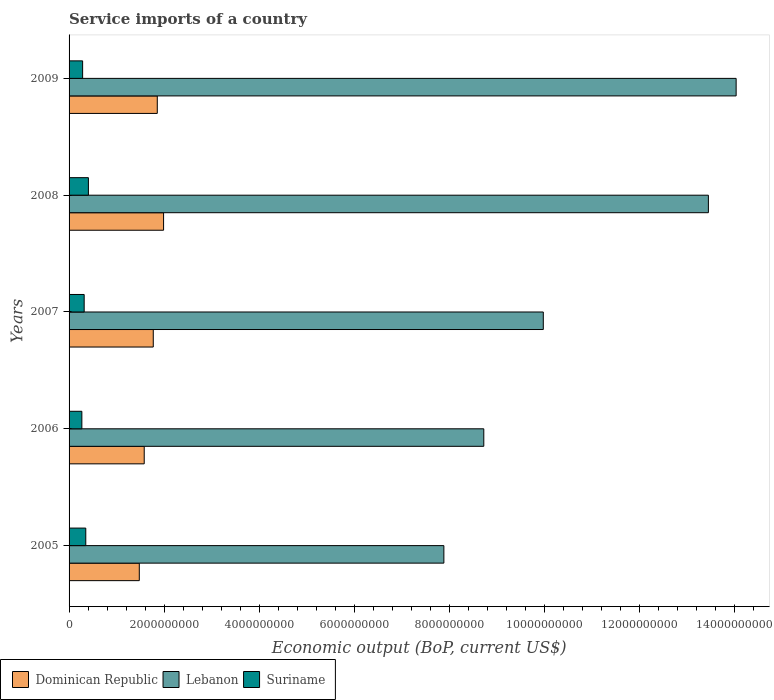How many different coloured bars are there?
Offer a terse response. 3. How many bars are there on the 1st tick from the top?
Your response must be concise. 3. What is the label of the 4th group of bars from the top?
Your answer should be very brief. 2006. In how many cases, is the number of bars for a given year not equal to the number of legend labels?
Your response must be concise. 0. What is the service imports in Lebanon in 2008?
Give a very brief answer. 1.35e+1. Across all years, what is the maximum service imports in Suriname?
Ensure brevity in your answer.  4.07e+08. Across all years, what is the minimum service imports in Dominican Republic?
Make the answer very short. 1.48e+09. In which year was the service imports in Lebanon minimum?
Offer a very short reply. 2005. What is the total service imports in Suriname in the graph?
Provide a short and direct response. 1.63e+09. What is the difference between the service imports in Lebanon in 2005 and that in 2007?
Your response must be concise. -2.09e+09. What is the difference between the service imports in Lebanon in 2008 and the service imports in Dominican Republic in 2007?
Make the answer very short. 1.17e+1. What is the average service imports in Dominican Republic per year?
Keep it short and to the point. 1.74e+09. In the year 2007, what is the difference between the service imports in Dominican Republic and service imports in Lebanon?
Your answer should be compact. -8.21e+09. What is the ratio of the service imports in Dominican Republic in 2005 to that in 2009?
Provide a short and direct response. 0.8. Is the service imports in Dominican Republic in 2005 less than that in 2009?
Give a very brief answer. Yes. What is the difference between the highest and the second highest service imports in Dominican Republic?
Your answer should be compact. 1.32e+08. What is the difference between the highest and the lowest service imports in Suriname?
Give a very brief answer. 1.38e+08. What does the 3rd bar from the top in 2007 represents?
Your answer should be very brief. Dominican Republic. What does the 2nd bar from the bottom in 2006 represents?
Keep it short and to the point. Lebanon. Is it the case that in every year, the sum of the service imports in Dominican Republic and service imports in Suriname is greater than the service imports in Lebanon?
Your answer should be compact. No. How many bars are there?
Provide a succinct answer. 15. Are all the bars in the graph horizontal?
Your answer should be very brief. Yes. What is the difference between two consecutive major ticks on the X-axis?
Your answer should be compact. 2.00e+09. Does the graph contain any zero values?
Provide a succinct answer. No. Does the graph contain grids?
Offer a very short reply. No. Where does the legend appear in the graph?
Give a very brief answer. Bottom left. How are the legend labels stacked?
Your response must be concise. Horizontal. What is the title of the graph?
Your answer should be compact. Service imports of a country. What is the label or title of the X-axis?
Offer a terse response. Economic output (BoP, current US$). What is the Economic output (BoP, current US$) of Dominican Republic in 2005?
Make the answer very short. 1.48e+09. What is the Economic output (BoP, current US$) of Lebanon in 2005?
Offer a terse response. 7.89e+09. What is the Economic output (BoP, current US$) in Suriname in 2005?
Your response must be concise. 3.52e+08. What is the Economic output (BoP, current US$) of Dominican Republic in 2006?
Your response must be concise. 1.58e+09. What is the Economic output (BoP, current US$) in Lebanon in 2006?
Give a very brief answer. 8.73e+09. What is the Economic output (BoP, current US$) in Suriname in 2006?
Your answer should be very brief. 2.69e+08. What is the Economic output (BoP, current US$) in Dominican Republic in 2007?
Your answer should be compact. 1.77e+09. What is the Economic output (BoP, current US$) in Lebanon in 2007?
Provide a short and direct response. 9.98e+09. What is the Economic output (BoP, current US$) of Suriname in 2007?
Make the answer very short. 3.18e+08. What is the Economic output (BoP, current US$) in Dominican Republic in 2008?
Provide a short and direct response. 1.99e+09. What is the Economic output (BoP, current US$) of Lebanon in 2008?
Make the answer very short. 1.35e+1. What is the Economic output (BoP, current US$) in Suriname in 2008?
Offer a terse response. 4.07e+08. What is the Economic output (BoP, current US$) of Dominican Republic in 2009?
Offer a very short reply. 1.86e+09. What is the Economic output (BoP, current US$) of Lebanon in 2009?
Offer a terse response. 1.40e+1. What is the Economic output (BoP, current US$) of Suriname in 2009?
Provide a succinct answer. 2.85e+08. Across all years, what is the maximum Economic output (BoP, current US$) of Dominican Republic?
Give a very brief answer. 1.99e+09. Across all years, what is the maximum Economic output (BoP, current US$) in Lebanon?
Provide a succinct answer. 1.40e+1. Across all years, what is the maximum Economic output (BoP, current US$) of Suriname?
Offer a very short reply. 4.07e+08. Across all years, what is the minimum Economic output (BoP, current US$) of Dominican Republic?
Ensure brevity in your answer.  1.48e+09. Across all years, what is the minimum Economic output (BoP, current US$) of Lebanon?
Provide a short and direct response. 7.89e+09. Across all years, what is the minimum Economic output (BoP, current US$) of Suriname?
Make the answer very short. 2.69e+08. What is the total Economic output (BoP, current US$) in Dominican Republic in the graph?
Your response must be concise. 8.68e+09. What is the total Economic output (BoP, current US$) in Lebanon in the graph?
Your response must be concise. 5.41e+1. What is the total Economic output (BoP, current US$) of Suriname in the graph?
Offer a very short reply. 1.63e+09. What is the difference between the Economic output (BoP, current US$) in Dominican Republic in 2005 and that in 2006?
Your response must be concise. -1.04e+08. What is the difference between the Economic output (BoP, current US$) of Lebanon in 2005 and that in 2006?
Your answer should be very brief. -8.40e+08. What is the difference between the Economic output (BoP, current US$) of Suriname in 2005 and that in 2006?
Your response must be concise. 8.25e+07. What is the difference between the Economic output (BoP, current US$) of Dominican Republic in 2005 and that in 2007?
Provide a short and direct response. -2.94e+08. What is the difference between the Economic output (BoP, current US$) in Lebanon in 2005 and that in 2007?
Offer a terse response. -2.09e+09. What is the difference between the Economic output (BoP, current US$) of Suriname in 2005 and that in 2007?
Your response must be concise. 3.39e+07. What is the difference between the Economic output (BoP, current US$) in Dominican Republic in 2005 and that in 2008?
Provide a short and direct response. -5.11e+08. What is the difference between the Economic output (BoP, current US$) in Lebanon in 2005 and that in 2008?
Provide a succinct answer. -5.57e+09. What is the difference between the Economic output (BoP, current US$) in Suriname in 2005 and that in 2008?
Your response must be concise. -5.54e+07. What is the difference between the Economic output (BoP, current US$) of Dominican Republic in 2005 and that in 2009?
Give a very brief answer. -3.79e+08. What is the difference between the Economic output (BoP, current US$) in Lebanon in 2005 and that in 2009?
Ensure brevity in your answer.  -6.15e+09. What is the difference between the Economic output (BoP, current US$) of Suriname in 2005 and that in 2009?
Your answer should be very brief. 6.65e+07. What is the difference between the Economic output (BoP, current US$) of Dominican Republic in 2006 and that in 2007?
Your answer should be compact. -1.90e+08. What is the difference between the Economic output (BoP, current US$) of Lebanon in 2006 and that in 2007?
Make the answer very short. -1.25e+09. What is the difference between the Economic output (BoP, current US$) in Suriname in 2006 and that in 2007?
Give a very brief answer. -4.86e+07. What is the difference between the Economic output (BoP, current US$) of Dominican Republic in 2006 and that in 2008?
Offer a very short reply. -4.07e+08. What is the difference between the Economic output (BoP, current US$) of Lebanon in 2006 and that in 2008?
Make the answer very short. -4.73e+09. What is the difference between the Economic output (BoP, current US$) of Suriname in 2006 and that in 2008?
Ensure brevity in your answer.  -1.38e+08. What is the difference between the Economic output (BoP, current US$) of Dominican Republic in 2006 and that in 2009?
Your answer should be very brief. -2.75e+08. What is the difference between the Economic output (BoP, current US$) of Lebanon in 2006 and that in 2009?
Provide a succinct answer. -5.31e+09. What is the difference between the Economic output (BoP, current US$) in Suriname in 2006 and that in 2009?
Provide a short and direct response. -1.60e+07. What is the difference between the Economic output (BoP, current US$) in Dominican Republic in 2007 and that in 2008?
Your response must be concise. -2.17e+08. What is the difference between the Economic output (BoP, current US$) of Lebanon in 2007 and that in 2008?
Your answer should be compact. -3.48e+09. What is the difference between the Economic output (BoP, current US$) in Suriname in 2007 and that in 2008?
Your answer should be very brief. -8.93e+07. What is the difference between the Economic output (BoP, current US$) in Dominican Republic in 2007 and that in 2009?
Ensure brevity in your answer.  -8.46e+07. What is the difference between the Economic output (BoP, current US$) in Lebanon in 2007 and that in 2009?
Provide a succinct answer. -4.06e+09. What is the difference between the Economic output (BoP, current US$) in Suriname in 2007 and that in 2009?
Ensure brevity in your answer.  3.26e+07. What is the difference between the Economic output (BoP, current US$) of Dominican Republic in 2008 and that in 2009?
Provide a short and direct response. 1.32e+08. What is the difference between the Economic output (BoP, current US$) in Lebanon in 2008 and that in 2009?
Make the answer very short. -5.84e+08. What is the difference between the Economic output (BoP, current US$) in Suriname in 2008 and that in 2009?
Give a very brief answer. 1.22e+08. What is the difference between the Economic output (BoP, current US$) in Dominican Republic in 2005 and the Economic output (BoP, current US$) in Lebanon in 2006?
Offer a terse response. -7.25e+09. What is the difference between the Economic output (BoP, current US$) in Dominican Republic in 2005 and the Economic output (BoP, current US$) in Suriname in 2006?
Your answer should be very brief. 1.21e+09. What is the difference between the Economic output (BoP, current US$) in Lebanon in 2005 and the Economic output (BoP, current US$) in Suriname in 2006?
Keep it short and to the point. 7.62e+09. What is the difference between the Economic output (BoP, current US$) of Dominican Republic in 2005 and the Economic output (BoP, current US$) of Lebanon in 2007?
Ensure brevity in your answer.  -8.50e+09. What is the difference between the Economic output (BoP, current US$) in Dominican Republic in 2005 and the Economic output (BoP, current US$) in Suriname in 2007?
Your answer should be very brief. 1.16e+09. What is the difference between the Economic output (BoP, current US$) in Lebanon in 2005 and the Economic output (BoP, current US$) in Suriname in 2007?
Your answer should be very brief. 7.57e+09. What is the difference between the Economic output (BoP, current US$) of Dominican Republic in 2005 and the Economic output (BoP, current US$) of Lebanon in 2008?
Your answer should be compact. -1.20e+1. What is the difference between the Economic output (BoP, current US$) in Dominican Republic in 2005 and the Economic output (BoP, current US$) in Suriname in 2008?
Offer a terse response. 1.07e+09. What is the difference between the Economic output (BoP, current US$) of Lebanon in 2005 and the Economic output (BoP, current US$) of Suriname in 2008?
Give a very brief answer. 7.48e+09. What is the difference between the Economic output (BoP, current US$) of Dominican Republic in 2005 and the Economic output (BoP, current US$) of Lebanon in 2009?
Keep it short and to the point. -1.26e+1. What is the difference between the Economic output (BoP, current US$) in Dominican Republic in 2005 and the Economic output (BoP, current US$) in Suriname in 2009?
Your answer should be very brief. 1.19e+09. What is the difference between the Economic output (BoP, current US$) of Lebanon in 2005 and the Economic output (BoP, current US$) of Suriname in 2009?
Provide a succinct answer. 7.60e+09. What is the difference between the Economic output (BoP, current US$) of Dominican Republic in 2006 and the Economic output (BoP, current US$) of Lebanon in 2007?
Your answer should be very brief. -8.40e+09. What is the difference between the Economic output (BoP, current US$) of Dominican Republic in 2006 and the Economic output (BoP, current US$) of Suriname in 2007?
Make the answer very short. 1.26e+09. What is the difference between the Economic output (BoP, current US$) of Lebanon in 2006 and the Economic output (BoP, current US$) of Suriname in 2007?
Give a very brief answer. 8.41e+09. What is the difference between the Economic output (BoP, current US$) of Dominican Republic in 2006 and the Economic output (BoP, current US$) of Lebanon in 2008?
Your answer should be very brief. -1.19e+1. What is the difference between the Economic output (BoP, current US$) of Dominican Republic in 2006 and the Economic output (BoP, current US$) of Suriname in 2008?
Offer a terse response. 1.17e+09. What is the difference between the Economic output (BoP, current US$) of Lebanon in 2006 and the Economic output (BoP, current US$) of Suriname in 2008?
Your response must be concise. 8.32e+09. What is the difference between the Economic output (BoP, current US$) of Dominican Republic in 2006 and the Economic output (BoP, current US$) of Lebanon in 2009?
Make the answer very short. -1.25e+1. What is the difference between the Economic output (BoP, current US$) in Dominican Republic in 2006 and the Economic output (BoP, current US$) in Suriname in 2009?
Offer a very short reply. 1.30e+09. What is the difference between the Economic output (BoP, current US$) of Lebanon in 2006 and the Economic output (BoP, current US$) of Suriname in 2009?
Your answer should be compact. 8.45e+09. What is the difference between the Economic output (BoP, current US$) of Dominican Republic in 2007 and the Economic output (BoP, current US$) of Lebanon in 2008?
Keep it short and to the point. -1.17e+1. What is the difference between the Economic output (BoP, current US$) of Dominican Republic in 2007 and the Economic output (BoP, current US$) of Suriname in 2008?
Provide a short and direct response. 1.37e+09. What is the difference between the Economic output (BoP, current US$) in Lebanon in 2007 and the Economic output (BoP, current US$) in Suriname in 2008?
Offer a very short reply. 9.58e+09. What is the difference between the Economic output (BoP, current US$) of Dominican Republic in 2007 and the Economic output (BoP, current US$) of Lebanon in 2009?
Provide a short and direct response. -1.23e+1. What is the difference between the Economic output (BoP, current US$) in Dominican Republic in 2007 and the Economic output (BoP, current US$) in Suriname in 2009?
Make the answer very short. 1.49e+09. What is the difference between the Economic output (BoP, current US$) of Lebanon in 2007 and the Economic output (BoP, current US$) of Suriname in 2009?
Make the answer very short. 9.70e+09. What is the difference between the Economic output (BoP, current US$) in Dominican Republic in 2008 and the Economic output (BoP, current US$) in Lebanon in 2009?
Give a very brief answer. -1.21e+1. What is the difference between the Economic output (BoP, current US$) of Dominican Republic in 2008 and the Economic output (BoP, current US$) of Suriname in 2009?
Provide a succinct answer. 1.70e+09. What is the difference between the Economic output (BoP, current US$) in Lebanon in 2008 and the Economic output (BoP, current US$) in Suriname in 2009?
Make the answer very short. 1.32e+1. What is the average Economic output (BoP, current US$) of Dominican Republic per year?
Make the answer very short. 1.74e+09. What is the average Economic output (BoP, current US$) in Lebanon per year?
Keep it short and to the point. 1.08e+1. What is the average Economic output (BoP, current US$) of Suriname per year?
Your response must be concise. 3.26e+08. In the year 2005, what is the difference between the Economic output (BoP, current US$) of Dominican Republic and Economic output (BoP, current US$) of Lebanon?
Give a very brief answer. -6.41e+09. In the year 2005, what is the difference between the Economic output (BoP, current US$) in Dominican Republic and Economic output (BoP, current US$) in Suriname?
Provide a succinct answer. 1.13e+09. In the year 2005, what is the difference between the Economic output (BoP, current US$) in Lebanon and Economic output (BoP, current US$) in Suriname?
Ensure brevity in your answer.  7.54e+09. In the year 2006, what is the difference between the Economic output (BoP, current US$) of Dominican Republic and Economic output (BoP, current US$) of Lebanon?
Give a very brief answer. -7.15e+09. In the year 2006, what is the difference between the Economic output (BoP, current US$) in Dominican Republic and Economic output (BoP, current US$) in Suriname?
Your answer should be compact. 1.31e+09. In the year 2006, what is the difference between the Economic output (BoP, current US$) in Lebanon and Economic output (BoP, current US$) in Suriname?
Your response must be concise. 8.46e+09. In the year 2007, what is the difference between the Economic output (BoP, current US$) in Dominican Republic and Economic output (BoP, current US$) in Lebanon?
Give a very brief answer. -8.21e+09. In the year 2007, what is the difference between the Economic output (BoP, current US$) of Dominican Republic and Economic output (BoP, current US$) of Suriname?
Ensure brevity in your answer.  1.45e+09. In the year 2007, what is the difference between the Economic output (BoP, current US$) in Lebanon and Economic output (BoP, current US$) in Suriname?
Offer a terse response. 9.67e+09. In the year 2008, what is the difference between the Economic output (BoP, current US$) in Dominican Republic and Economic output (BoP, current US$) in Lebanon?
Your response must be concise. -1.15e+1. In the year 2008, what is the difference between the Economic output (BoP, current US$) of Dominican Republic and Economic output (BoP, current US$) of Suriname?
Your response must be concise. 1.58e+09. In the year 2008, what is the difference between the Economic output (BoP, current US$) in Lebanon and Economic output (BoP, current US$) in Suriname?
Your answer should be compact. 1.31e+1. In the year 2009, what is the difference between the Economic output (BoP, current US$) of Dominican Republic and Economic output (BoP, current US$) of Lebanon?
Provide a short and direct response. -1.22e+1. In the year 2009, what is the difference between the Economic output (BoP, current US$) in Dominican Republic and Economic output (BoP, current US$) in Suriname?
Make the answer very short. 1.57e+09. In the year 2009, what is the difference between the Economic output (BoP, current US$) of Lebanon and Economic output (BoP, current US$) of Suriname?
Provide a short and direct response. 1.38e+1. What is the ratio of the Economic output (BoP, current US$) in Dominican Republic in 2005 to that in 2006?
Offer a very short reply. 0.93. What is the ratio of the Economic output (BoP, current US$) of Lebanon in 2005 to that in 2006?
Your answer should be very brief. 0.9. What is the ratio of the Economic output (BoP, current US$) of Suriname in 2005 to that in 2006?
Keep it short and to the point. 1.31. What is the ratio of the Economic output (BoP, current US$) of Dominican Republic in 2005 to that in 2007?
Provide a succinct answer. 0.83. What is the ratio of the Economic output (BoP, current US$) of Lebanon in 2005 to that in 2007?
Offer a terse response. 0.79. What is the ratio of the Economic output (BoP, current US$) in Suriname in 2005 to that in 2007?
Give a very brief answer. 1.11. What is the ratio of the Economic output (BoP, current US$) of Dominican Republic in 2005 to that in 2008?
Keep it short and to the point. 0.74. What is the ratio of the Economic output (BoP, current US$) in Lebanon in 2005 to that in 2008?
Make the answer very short. 0.59. What is the ratio of the Economic output (BoP, current US$) in Suriname in 2005 to that in 2008?
Offer a very short reply. 0.86. What is the ratio of the Economic output (BoP, current US$) of Dominican Republic in 2005 to that in 2009?
Your answer should be very brief. 0.8. What is the ratio of the Economic output (BoP, current US$) in Lebanon in 2005 to that in 2009?
Make the answer very short. 0.56. What is the ratio of the Economic output (BoP, current US$) of Suriname in 2005 to that in 2009?
Offer a very short reply. 1.23. What is the ratio of the Economic output (BoP, current US$) in Dominican Republic in 2006 to that in 2007?
Your answer should be very brief. 0.89. What is the ratio of the Economic output (BoP, current US$) of Lebanon in 2006 to that in 2007?
Give a very brief answer. 0.87. What is the ratio of the Economic output (BoP, current US$) of Suriname in 2006 to that in 2007?
Provide a succinct answer. 0.85. What is the ratio of the Economic output (BoP, current US$) of Dominican Republic in 2006 to that in 2008?
Give a very brief answer. 0.8. What is the ratio of the Economic output (BoP, current US$) in Lebanon in 2006 to that in 2008?
Offer a very short reply. 0.65. What is the ratio of the Economic output (BoP, current US$) of Suriname in 2006 to that in 2008?
Offer a very short reply. 0.66. What is the ratio of the Economic output (BoP, current US$) of Dominican Republic in 2006 to that in 2009?
Keep it short and to the point. 0.85. What is the ratio of the Economic output (BoP, current US$) in Lebanon in 2006 to that in 2009?
Ensure brevity in your answer.  0.62. What is the ratio of the Economic output (BoP, current US$) of Suriname in 2006 to that in 2009?
Your response must be concise. 0.94. What is the ratio of the Economic output (BoP, current US$) in Dominican Republic in 2007 to that in 2008?
Your answer should be compact. 0.89. What is the ratio of the Economic output (BoP, current US$) of Lebanon in 2007 to that in 2008?
Your response must be concise. 0.74. What is the ratio of the Economic output (BoP, current US$) in Suriname in 2007 to that in 2008?
Offer a terse response. 0.78. What is the ratio of the Economic output (BoP, current US$) in Dominican Republic in 2007 to that in 2009?
Offer a terse response. 0.95. What is the ratio of the Economic output (BoP, current US$) of Lebanon in 2007 to that in 2009?
Give a very brief answer. 0.71. What is the ratio of the Economic output (BoP, current US$) in Suriname in 2007 to that in 2009?
Offer a very short reply. 1.11. What is the ratio of the Economic output (BoP, current US$) in Dominican Republic in 2008 to that in 2009?
Offer a very short reply. 1.07. What is the ratio of the Economic output (BoP, current US$) of Lebanon in 2008 to that in 2009?
Offer a very short reply. 0.96. What is the ratio of the Economic output (BoP, current US$) in Suriname in 2008 to that in 2009?
Offer a very short reply. 1.43. What is the difference between the highest and the second highest Economic output (BoP, current US$) of Dominican Republic?
Offer a very short reply. 1.32e+08. What is the difference between the highest and the second highest Economic output (BoP, current US$) in Lebanon?
Make the answer very short. 5.84e+08. What is the difference between the highest and the second highest Economic output (BoP, current US$) of Suriname?
Give a very brief answer. 5.54e+07. What is the difference between the highest and the lowest Economic output (BoP, current US$) in Dominican Republic?
Provide a succinct answer. 5.11e+08. What is the difference between the highest and the lowest Economic output (BoP, current US$) in Lebanon?
Offer a very short reply. 6.15e+09. What is the difference between the highest and the lowest Economic output (BoP, current US$) of Suriname?
Your response must be concise. 1.38e+08. 